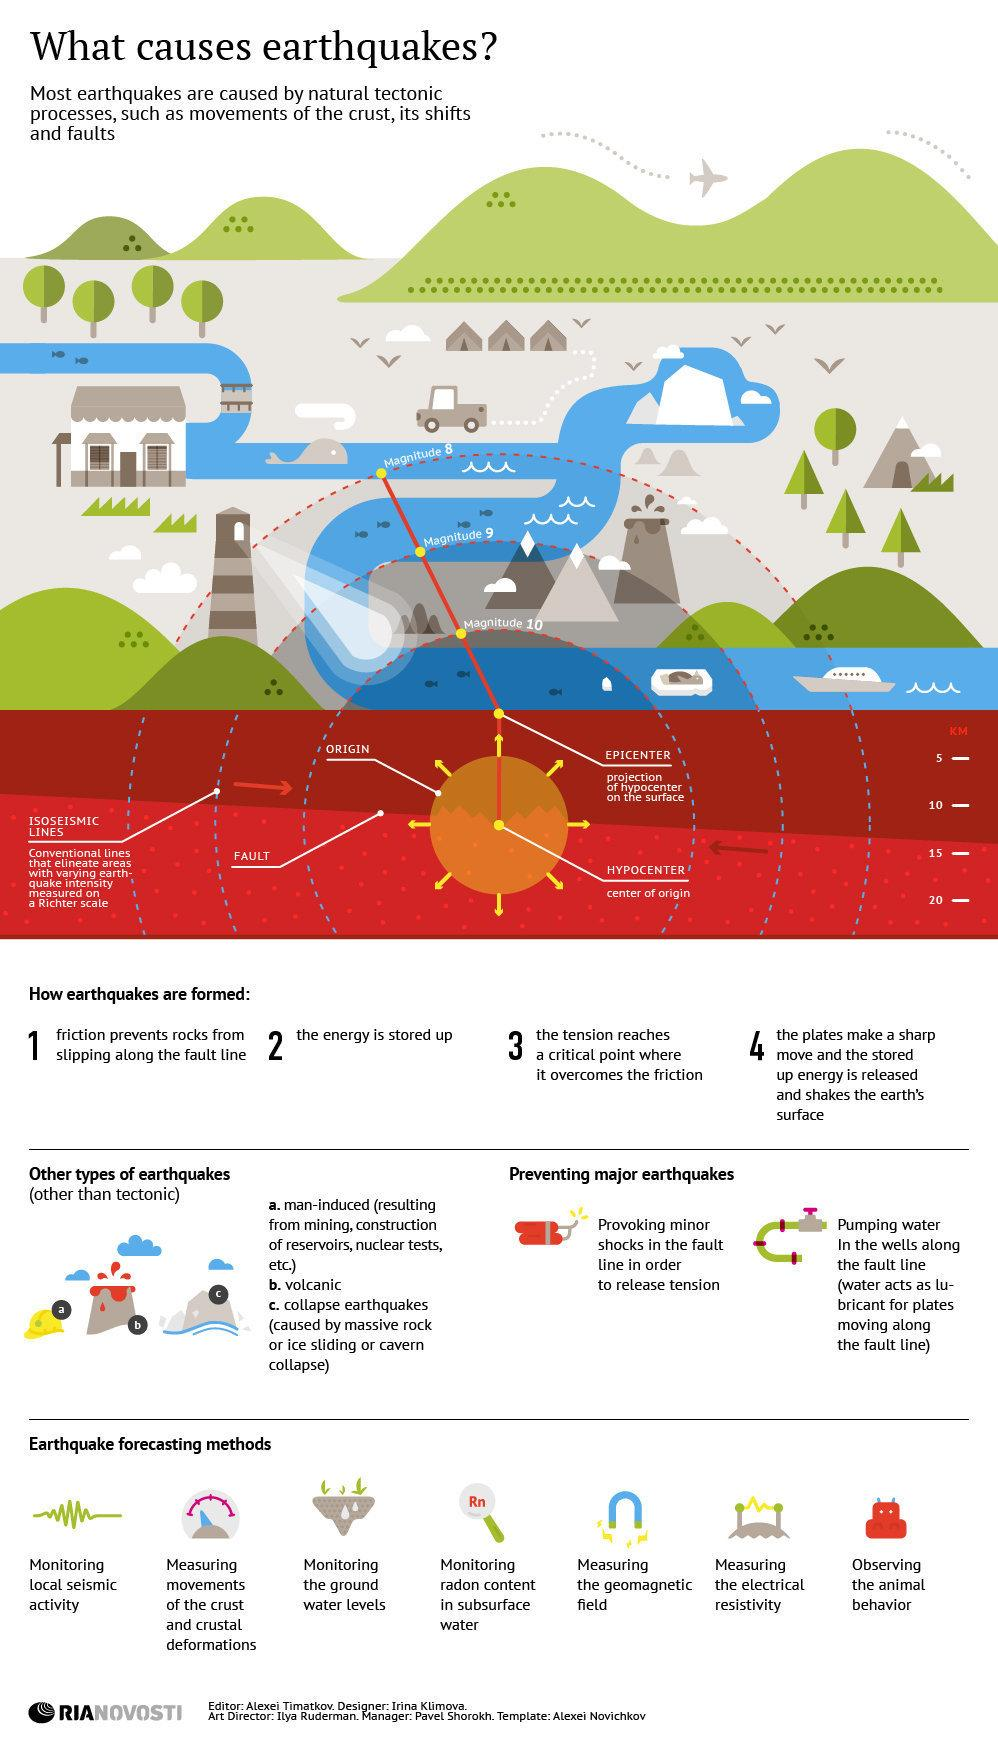Give some essential details in this illustration. The "centre of origin" and "hypocenter" are terms used in seismology to describe the point at which an earthquake originates and the resulting seismic waves are thought to have originated. The "centre of origin" is the point on the Earth's surface that is directly above the hypocenter, while the "hypocenter" is the point on the Earth's surface that is directly beneath the focus of the earthquake. Understanding the relationship between the "centre of origin" and "hypocenter" helps scientists to better understand the nature and causes of earthquakes. The Richter scale is used to measure the intensity of earthquakes. It is a logarithmic scale that assigns a number to the magnitude of an earthquake based on the size of its seismic waves. The Richter scale is the most commonly used scale for measuring the intensity of earthquakes and is widely recognized as a standard for earthquake magnitude. The Richter scale ranges from 0 to 9.9, with each whole number representing a tenfold increase in magnitude. The higher the number on the Richter scale, the more intense the earthquake. 